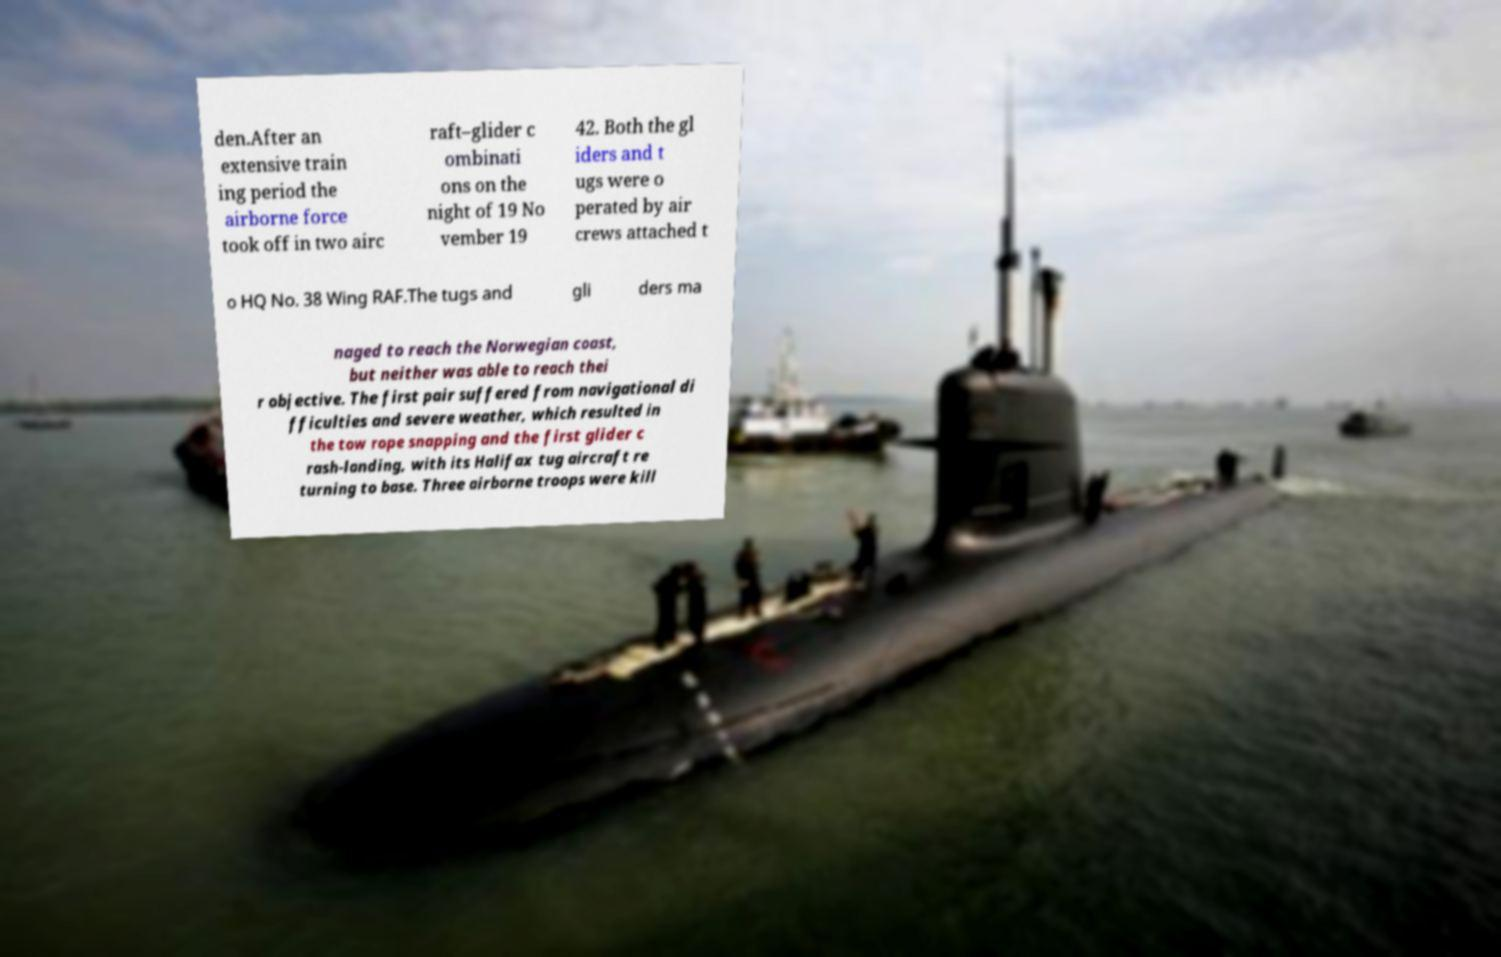Could you extract and type out the text from this image? den.After an extensive train ing period the airborne force took off in two airc raft–glider c ombinati ons on the night of 19 No vember 19 42. Both the gl iders and t ugs were o perated by air crews attached t o HQ No. 38 Wing RAF.The tugs and gli ders ma naged to reach the Norwegian coast, but neither was able to reach thei r objective. The first pair suffered from navigational di fficulties and severe weather, which resulted in the tow rope snapping and the first glider c rash-landing, with its Halifax tug aircraft re turning to base. Three airborne troops were kill 